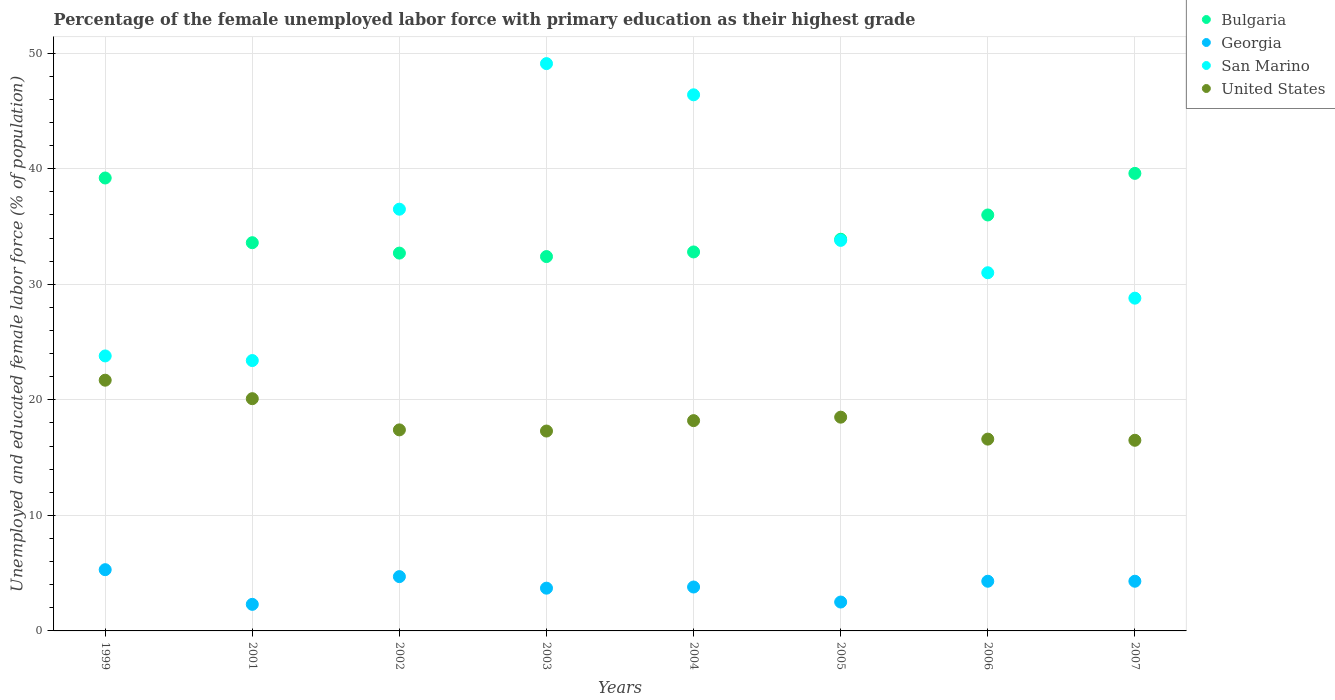How many different coloured dotlines are there?
Give a very brief answer. 4. Is the number of dotlines equal to the number of legend labels?
Offer a terse response. Yes. What is the percentage of the unemployed female labor force with primary education in United States in 2002?
Offer a very short reply. 17.4. Across all years, what is the maximum percentage of the unemployed female labor force with primary education in Bulgaria?
Ensure brevity in your answer.  39.6. Across all years, what is the minimum percentage of the unemployed female labor force with primary education in San Marino?
Your answer should be very brief. 23.4. In which year was the percentage of the unemployed female labor force with primary education in San Marino minimum?
Offer a terse response. 2001. What is the total percentage of the unemployed female labor force with primary education in Bulgaria in the graph?
Keep it short and to the point. 280.2. What is the difference between the percentage of the unemployed female labor force with primary education in United States in 2003 and that in 2006?
Offer a terse response. 0.7. What is the difference between the percentage of the unemployed female labor force with primary education in San Marino in 2006 and the percentage of the unemployed female labor force with primary education in Georgia in 2005?
Ensure brevity in your answer.  28.5. What is the average percentage of the unemployed female labor force with primary education in Bulgaria per year?
Give a very brief answer. 35.03. In the year 2005, what is the difference between the percentage of the unemployed female labor force with primary education in United States and percentage of the unemployed female labor force with primary education in San Marino?
Provide a short and direct response. -15.3. In how many years, is the percentage of the unemployed female labor force with primary education in United States greater than 18 %?
Ensure brevity in your answer.  4. What is the ratio of the percentage of the unemployed female labor force with primary education in United States in 2002 to that in 2003?
Provide a short and direct response. 1.01. Is the percentage of the unemployed female labor force with primary education in San Marino in 1999 less than that in 2006?
Your answer should be very brief. Yes. What is the difference between the highest and the second highest percentage of the unemployed female labor force with primary education in Bulgaria?
Give a very brief answer. 0.4. What is the difference between the highest and the lowest percentage of the unemployed female labor force with primary education in Bulgaria?
Your answer should be very brief. 7.2. Is the sum of the percentage of the unemployed female labor force with primary education in San Marino in 2001 and 2002 greater than the maximum percentage of the unemployed female labor force with primary education in Bulgaria across all years?
Ensure brevity in your answer.  Yes. Is the percentage of the unemployed female labor force with primary education in Georgia strictly less than the percentage of the unemployed female labor force with primary education in San Marino over the years?
Keep it short and to the point. Yes. How many dotlines are there?
Your answer should be very brief. 4. Are the values on the major ticks of Y-axis written in scientific E-notation?
Give a very brief answer. No. What is the title of the graph?
Give a very brief answer. Percentage of the female unemployed labor force with primary education as their highest grade. Does "Niger" appear as one of the legend labels in the graph?
Your answer should be compact. No. What is the label or title of the Y-axis?
Keep it short and to the point. Unemployed and educated female labor force (% of population). What is the Unemployed and educated female labor force (% of population) in Bulgaria in 1999?
Your answer should be very brief. 39.2. What is the Unemployed and educated female labor force (% of population) of Georgia in 1999?
Keep it short and to the point. 5.3. What is the Unemployed and educated female labor force (% of population) of San Marino in 1999?
Your answer should be very brief. 23.8. What is the Unemployed and educated female labor force (% of population) in United States in 1999?
Your answer should be very brief. 21.7. What is the Unemployed and educated female labor force (% of population) of Bulgaria in 2001?
Your answer should be compact. 33.6. What is the Unemployed and educated female labor force (% of population) in Georgia in 2001?
Your response must be concise. 2.3. What is the Unemployed and educated female labor force (% of population) in San Marino in 2001?
Make the answer very short. 23.4. What is the Unemployed and educated female labor force (% of population) of United States in 2001?
Your response must be concise. 20.1. What is the Unemployed and educated female labor force (% of population) of Bulgaria in 2002?
Make the answer very short. 32.7. What is the Unemployed and educated female labor force (% of population) in Georgia in 2002?
Provide a succinct answer. 4.7. What is the Unemployed and educated female labor force (% of population) of San Marino in 2002?
Give a very brief answer. 36.5. What is the Unemployed and educated female labor force (% of population) of United States in 2002?
Your answer should be very brief. 17.4. What is the Unemployed and educated female labor force (% of population) of Bulgaria in 2003?
Offer a very short reply. 32.4. What is the Unemployed and educated female labor force (% of population) of Georgia in 2003?
Provide a short and direct response. 3.7. What is the Unemployed and educated female labor force (% of population) of San Marino in 2003?
Offer a very short reply. 49.1. What is the Unemployed and educated female labor force (% of population) in United States in 2003?
Offer a terse response. 17.3. What is the Unemployed and educated female labor force (% of population) in Bulgaria in 2004?
Offer a very short reply. 32.8. What is the Unemployed and educated female labor force (% of population) in Georgia in 2004?
Your answer should be compact. 3.8. What is the Unemployed and educated female labor force (% of population) in San Marino in 2004?
Provide a short and direct response. 46.4. What is the Unemployed and educated female labor force (% of population) of United States in 2004?
Offer a terse response. 18.2. What is the Unemployed and educated female labor force (% of population) of Bulgaria in 2005?
Your answer should be very brief. 33.9. What is the Unemployed and educated female labor force (% of population) of San Marino in 2005?
Offer a very short reply. 33.8. What is the Unemployed and educated female labor force (% of population) in Bulgaria in 2006?
Your answer should be very brief. 36. What is the Unemployed and educated female labor force (% of population) in Georgia in 2006?
Give a very brief answer. 4.3. What is the Unemployed and educated female labor force (% of population) of United States in 2006?
Give a very brief answer. 16.6. What is the Unemployed and educated female labor force (% of population) of Bulgaria in 2007?
Ensure brevity in your answer.  39.6. What is the Unemployed and educated female labor force (% of population) in Georgia in 2007?
Your answer should be very brief. 4.3. What is the Unemployed and educated female labor force (% of population) in San Marino in 2007?
Your response must be concise. 28.8. Across all years, what is the maximum Unemployed and educated female labor force (% of population) of Bulgaria?
Your answer should be compact. 39.6. Across all years, what is the maximum Unemployed and educated female labor force (% of population) of Georgia?
Offer a very short reply. 5.3. Across all years, what is the maximum Unemployed and educated female labor force (% of population) in San Marino?
Make the answer very short. 49.1. Across all years, what is the maximum Unemployed and educated female labor force (% of population) of United States?
Make the answer very short. 21.7. Across all years, what is the minimum Unemployed and educated female labor force (% of population) in Bulgaria?
Your answer should be compact. 32.4. Across all years, what is the minimum Unemployed and educated female labor force (% of population) of Georgia?
Offer a very short reply. 2.3. Across all years, what is the minimum Unemployed and educated female labor force (% of population) in San Marino?
Make the answer very short. 23.4. Across all years, what is the minimum Unemployed and educated female labor force (% of population) in United States?
Your answer should be very brief. 16.5. What is the total Unemployed and educated female labor force (% of population) of Bulgaria in the graph?
Offer a terse response. 280.2. What is the total Unemployed and educated female labor force (% of population) of Georgia in the graph?
Offer a very short reply. 30.9. What is the total Unemployed and educated female labor force (% of population) of San Marino in the graph?
Your answer should be compact. 272.8. What is the total Unemployed and educated female labor force (% of population) of United States in the graph?
Ensure brevity in your answer.  146.3. What is the difference between the Unemployed and educated female labor force (% of population) of Bulgaria in 1999 and that in 2001?
Provide a short and direct response. 5.6. What is the difference between the Unemployed and educated female labor force (% of population) in Georgia in 1999 and that in 2001?
Keep it short and to the point. 3. What is the difference between the Unemployed and educated female labor force (% of population) of United States in 1999 and that in 2001?
Ensure brevity in your answer.  1.6. What is the difference between the Unemployed and educated female labor force (% of population) in Bulgaria in 1999 and that in 2002?
Offer a very short reply. 6.5. What is the difference between the Unemployed and educated female labor force (% of population) in Georgia in 1999 and that in 2003?
Your answer should be very brief. 1.6. What is the difference between the Unemployed and educated female labor force (% of population) in San Marino in 1999 and that in 2003?
Your answer should be very brief. -25.3. What is the difference between the Unemployed and educated female labor force (% of population) in San Marino in 1999 and that in 2004?
Offer a terse response. -22.6. What is the difference between the Unemployed and educated female labor force (% of population) in United States in 1999 and that in 2005?
Give a very brief answer. 3.2. What is the difference between the Unemployed and educated female labor force (% of population) in Georgia in 1999 and that in 2006?
Your answer should be compact. 1. What is the difference between the Unemployed and educated female labor force (% of population) in San Marino in 1999 and that in 2006?
Give a very brief answer. -7.2. What is the difference between the Unemployed and educated female labor force (% of population) in San Marino in 1999 and that in 2007?
Provide a succinct answer. -5. What is the difference between the Unemployed and educated female labor force (% of population) in United States in 1999 and that in 2007?
Give a very brief answer. 5.2. What is the difference between the Unemployed and educated female labor force (% of population) in Bulgaria in 2001 and that in 2002?
Offer a terse response. 0.9. What is the difference between the Unemployed and educated female labor force (% of population) of United States in 2001 and that in 2002?
Provide a short and direct response. 2.7. What is the difference between the Unemployed and educated female labor force (% of population) in Georgia in 2001 and that in 2003?
Provide a short and direct response. -1.4. What is the difference between the Unemployed and educated female labor force (% of population) of San Marino in 2001 and that in 2003?
Ensure brevity in your answer.  -25.7. What is the difference between the Unemployed and educated female labor force (% of population) of United States in 2001 and that in 2004?
Your answer should be very brief. 1.9. What is the difference between the Unemployed and educated female labor force (% of population) in Bulgaria in 2001 and that in 2005?
Ensure brevity in your answer.  -0.3. What is the difference between the Unemployed and educated female labor force (% of population) of United States in 2001 and that in 2005?
Keep it short and to the point. 1.6. What is the difference between the Unemployed and educated female labor force (% of population) in San Marino in 2001 and that in 2006?
Your answer should be very brief. -7.6. What is the difference between the Unemployed and educated female labor force (% of population) in United States in 2001 and that in 2006?
Keep it short and to the point. 3.5. What is the difference between the Unemployed and educated female labor force (% of population) of Bulgaria in 2001 and that in 2007?
Give a very brief answer. -6. What is the difference between the Unemployed and educated female labor force (% of population) of United States in 2001 and that in 2007?
Give a very brief answer. 3.6. What is the difference between the Unemployed and educated female labor force (% of population) of Bulgaria in 2002 and that in 2003?
Your answer should be compact. 0.3. What is the difference between the Unemployed and educated female labor force (% of population) of Georgia in 2002 and that in 2003?
Offer a very short reply. 1. What is the difference between the Unemployed and educated female labor force (% of population) of United States in 2002 and that in 2003?
Make the answer very short. 0.1. What is the difference between the Unemployed and educated female labor force (% of population) of Bulgaria in 2002 and that in 2004?
Provide a succinct answer. -0.1. What is the difference between the Unemployed and educated female labor force (% of population) in Georgia in 2002 and that in 2004?
Your answer should be very brief. 0.9. What is the difference between the Unemployed and educated female labor force (% of population) in San Marino in 2002 and that in 2004?
Give a very brief answer. -9.9. What is the difference between the Unemployed and educated female labor force (% of population) of United States in 2002 and that in 2004?
Your response must be concise. -0.8. What is the difference between the Unemployed and educated female labor force (% of population) in Bulgaria in 2002 and that in 2005?
Offer a terse response. -1.2. What is the difference between the Unemployed and educated female labor force (% of population) in San Marino in 2002 and that in 2005?
Your answer should be compact. 2.7. What is the difference between the Unemployed and educated female labor force (% of population) of San Marino in 2002 and that in 2006?
Offer a terse response. 5.5. What is the difference between the Unemployed and educated female labor force (% of population) in United States in 2002 and that in 2006?
Your answer should be compact. 0.8. What is the difference between the Unemployed and educated female labor force (% of population) of San Marino in 2002 and that in 2007?
Your answer should be compact. 7.7. What is the difference between the Unemployed and educated female labor force (% of population) in San Marino in 2003 and that in 2004?
Provide a succinct answer. 2.7. What is the difference between the Unemployed and educated female labor force (% of population) of United States in 2003 and that in 2004?
Keep it short and to the point. -0.9. What is the difference between the Unemployed and educated female labor force (% of population) in Bulgaria in 2003 and that in 2005?
Keep it short and to the point. -1.5. What is the difference between the Unemployed and educated female labor force (% of population) of San Marino in 2003 and that in 2005?
Your response must be concise. 15.3. What is the difference between the Unemployed and educated female labor force (% of population) in San Marino in 2003 and that in 2006?
Your response must be concise. 18.1. What is the difference between the Unemployed and educated female labor force (% of population) in Bulgaria in 2003 and that in 2007?
Provide a short and direct response. -7.2. What is the difference between the Unemployed and educated female labor force (% of population) of San Marino in 2003 and that in 2007?
Ensure brevity in your answer.  20.3. What is the difference between the Unemployed and educated female labor force (% of population) of United States in 2003 and that in 2007?
Offer a terse response. 0.8. What is the difference between the Unemployed and educated female labor force (% of population) in San Marino in 2004 and that in 2005?
Your answer should be compact. 12.6. What is the difference between the Unemployed and educated female labor force (% of population) of San Marino in 2004 and that in 2006?
Give a very brief answer. 15.4. What is the difference between the Unemployed and educated female labor force (% of population) in United States in 2004 and that in 2006?
Your answer should be compact. 1.6. What is the difference between the Unemployed and educated female labor force (% of population) of Bulgaria in 2004 and that in 2007?
Keep it short and to the point. -6.8. What is the difference between the Unemployed and educated female labor force (% of population) in Georgia in 2004 and that in 2007?
Your answer should be very brief. -0.5. What is the difference between the Unemployed and educated female labor force (% of population) of Bulgaria in 2005 and that in 2006?
Provide a succinct answer. -2.1. What is the difference between the Unemployed and educated female labor force (% of population) of Georgia in 2005 and that in 2006?
Provide a succinct answer. -1.8. What is the difference between the Unemployed and educated female labor force (% of population) in San Marino in 2005 and that in 2006?
Ensure brevity in your answer.  2.8. What is the difference between the Unemployed and educated female labor force (% of population) of San Marino in 2005 and that in 2007?
Your answer should be very brief. 5. What is the difference between the Unemployed and educated female labor force (% of population) of Bulgaria in 2006 and that in 2007?
Give a very brief answer. -3.6. What is the difference between the Unemployed and educated female labor force (% of population) of United States in 2006 and that in 2007?
Your answer should be very brief. 0.1. What is the difference between the Unemployed and educated female labor force (% of population) of Bulgaria in 1999 and the Unemployed and educated female labor force (% of population) of Georgia in 2001?
Give a very brief answer. 36.9. What is the difference between the Unemployed and educated female labor force (% of population) of Bulgaria in 1999 and the Unemployed and educated female labor force (% of population) of San Marino in 2001?
Provide a succinct answer. 15.8. What is the difference between the Unemployed and educated female labor force (% of population) in Georgia in 1999 and the Unemployed and educated female labor force (% of population) in San Marino in 2001?
Ensure brevity in your answer.  -18.1. What is the difference between the Unemployed and educated female labor force (% of population) in Georgia in 1999 and the Unemployed and educated female labor force (% of population) in United States in 2001?
Make the answer very short. -14.8. What is the difference between the Unemployed and educated female labor force (% of population) in Bulgaria in 1999 and the Unemployed and educated female labor force (% of population) in Georgia in 2002?
Your answer should be compact. 34.5. What is the difference between the Unemployed and educated female labor force (% of population) of Bulgaria in 1999 and the Unemployed and educated female labor force (% of population) of United States in 2002?
Your response must be concise. 21.8. What is the difference between the Unemployed and educated female labor force (% of population) in Georgia in 1999 and the Unemployed and educated female labor force (% of population) in San Marino in 2002?
Your response must be concise. -31.2. What is the difference between the Unemployed and educated female labor force (% of population) in San Marino in 1999 and the Unemployed and educated female labor force (% of population) in United States in 2002?
Your answer should be very brief. 6.4. What is the difference between the Unemployed and educated female labor force (% of population) in Bulgaria in 1999 and the Unemployed and educated female labor force (% of population) in Georgia in 2003?
Ensure brevity in your answer.  35.5. What is the difference between the Unemployed and educated female labor force (% of population) in Bulgaria in 1999 and the Unemployed and educated female labor force (% of population) in San Marino in 2003?
Ensure brevity in your answer.  -9.9. What is the difference between the Unemployed and educated female labor force (% of population) of Bulgaria in 1999 and the Unemployed and educated female labor force (% of population) of United States in 2003?
Keep it short and to the point. 21.9. What is the difference between the Unemployed and educated female labor force (% of population) of Georgia in 1999 and the Unemployed and educated female labor force (% of population) of San Marino in 2003?
Your answer should be compact. -43.8. What is the difference between the Unemployed and educated female labor force (% of population) in Bulgaria in 1999 and the Unemployed and educated female labor force (% of population) in Georgia in 2004?
Provide a short and direct response. 35.4. What is the difference between the Unemployed and educated female labor force (% of population) in Bulgaria in 1999 and the Unemployed and educated female labor force (% of population) in San Marino in 2004?
Your answer should be compact. -7.2. What is the difference between the Unemployed and educated female labor force (% of population) of Bulgaria in 1999 and the Unemployed and educated female labor force (% of population) of United States in 2004?
Ensure brevity in your answer.  21. What is the difference between the Unemployed and educated female labor force (% of population) in Georgia in 1999 and the Unemployed and educated female labor force (% of population) in San Marino in 2004?
Your answer should be compact. -41.1. What is the difference between the Unemployed and educated female labor force (% of population) of Bulgaria in 1999 and the Unemployed and educated female labor force (% of population) of Georgia in 2005?
Make the answer very short. 36.7. What is the difference between the Unemployed and educated female labor force (% of population) of Bulgaria in 1999 and the Unemployed and educated female labor force (% of population) of United States in 2005?
Give a very brief answer. 20.7. What is the difference between the Unemployed and educated female labor force (% of population) in Georgia in 1999 and the Unemployed and educated female labor force (% of population) in San Marino in 2005?
Your response must be concise. -28.5. What is the difference between the Unemployed and educated female labor force (% of population) of Georgia in 1999 and the Unemployed and educated female labor force (% of population) of United States in 2005?
Make the answer very short. -13.2. What is the difference between the Unemployed and educated female labor force (% of population) in San Marino in 1999 and the Unemployed and educated female labor force (% of population) in United States in 2005?
Offer a terse response. 5.3. What is the difference between the Unemployed and educated female labor force (% of population) of Bulgaria in 1999 and the Unemployed and educated female labor force (% of population) of Georgia in 2006?
Provide a succinct answer. 34.9. What is the difference between the Unemployed and educated female labor force (% of population) in Bulgaria in 1999 and the Unemployed and educated female labor force (% of population) in San Marino in 2006?
Keep it short and to the point. 8.2. What is the difference between the Unemployed and educated female labor force (% of population) in Bulgaria in 1999 and the Unemployed and educated female labor force (% of population) in United States in 2006?
Make the answer very short. 22.6. What is the difference between the Unemployed and educated female labor force (% of population) in Georgia in 1999 and the Unemployed and educated female labor force (% of population) in San Marino in 2006?
Keep it short and to the point. -25.7. What is the difference between the Unemployed and educated female labor force (% of population) of Georgia in 1999 and the Unemployed and educated female labor force (% of population) of United States in 2006?
Your response must be concise. -11.3. What is the difference between the Unemployed and educated female labor force (% of population) of San Marino in 1999 and the Unemployed and educated female labor force (% of population) of United States in 2006?
Offer a very short reply. 7.2. What is the difference between the Unemployed and educated female labor force (% of population) of Bulgaria in 1999 and the Unemployed and educated female labor force (% of population) of Georgia in 2007?
Your answer should be compact. 34.9. What is the difference between the Unemployed and educated female labor force (% of population) of Bulgaria in 1999 and the Unemployed and educated female labor force (% of population) of San Marino in 2007?
Your response must be concise. 10.4. What is the difference between the Unemployed and educated female labor force (% of population) in Bulgaria in 1999 and the Unemployed and educated female labor force (% of population) in United States in 2007?
Offer a very short reply. 22.7. What is the difference between the Unemployed and educated female labor force (% of population) in Georgia in 1999 and the Unemployed and educated female labor force (% of population) in San Marino in 2007?
Your answer should be compact. -23.5. What is the difference between the Unemployed and educated female labor force (% of population) in Georgia in 1999 and the Unemployed and educated female labor force (% of population) in United States in 2007?
Provide a succinct answer. -11.2. What is the difference between the Unemployed and educated female labor force (% of population) of Bulgaria in 2001 and the Unemployed and educated female labor force (% of population) of Georgia in 2002?
Provide a short and direct response. 28.9. What is the difference between the Unemployed and educated female labor force (% of population) in Bulgaria in 2001 and the Unemployed and educated female labor force (% of population) in San Marino in 2002?
Your answer should be very brief. -2.9. What is the difference between the Unemployed and educated female labor force (% of population) in Georgia in 2001 and the Unemployed and educated female labor force (% of population) in San Marino in 2002?
Your answer should be very brief. -34.2. What is the difference between the Unemployed and educated female labor force (% of population) in Georgia in 2001 and the Unemployed and educated female labor force (% of population) in United States in 2002?
Offer a terse response. -15.1. What is the difference between the Unemployed and educated female labor force (% of population) of San Marino in 2001 and the Unemployed and educated female labor force (% of population) of United States in 2002?
Offer a very short reply. 6. What is the difference between the Unemployed and educated female labor force (% of population) of Bulgaria in 2001 and the Unemployed and educated female labor force (% of population) of Georgia in 2003?
Make the answer very short. 29.9. What is the difference between the Unemployed and educated female labor force (% of population) in Bulgaria in 2001 and the Unemployed and educated female labor force (% of population) in San Marino in 2003?
Offer a very short reply. -15.5. What is the difference between the Unemployed and educated female labor force (% of population) of Georgia in 2001 and the Unemployed and educated female labor force (% of population) of San Marino in 2003?
Your response must be concise. -46.8. What is the difference between the Unemployed and educated female labor force (% of population) in Georgia in 2001 and the Unemployed and educated female labor force (% of population) in United States in 2003?
Your response must be concise. -15. What is the difference between the Unemployed and educated female labor force (% of population) of San Marino in 2001 and the Unemployed and educated female labor force (% of population) of United States in 2003?
Your answer should be compact. 6.1. What is the difference between the Unemployed and educated female labor force (% of population) in Bulgaria in 2001 and the Unemployed and educated female labor force (% of population) in Georgia in 2004?
Offer a very short reply. 29.8. What is the difference between the Unemployed and educated female labor force (% of population) of Bulgaria in 2001 and the Unemployed and educated female labor force (% of population) of United States in 2004?
Give a very brief answer. 15.4. What is the difference between the Unemployed and educated female labor force (% of population) of Georgia in 2001 and the Unemployed and educated female labor force (% of population) of San Marino in 2004?
Keep it short and to the point. -44.1. What is the difference between the Unemployed and educated female labor force (% of population) in Georgia in 2001 and the Unemployed and educated female labor force (% of population) in United States in 2004?
Offer a very short reply. -15.9. What is the difference between the Unemployed and educated female labor force (% of population) of Bulgaria in 2001 and the Unemployed and educated female labor force (% of population) of Georgia in 2005?
Your response must be concise. 31.1. What is the difference between the Unemployed and educated female labor force (% of population) in Bulgaria in 2001 and the Unemployed and educated female labor force (% of population) in San Marino in 2005?
Give a very brief answer. -0.2. What is the difference between the Unemployed and educated female labor force (% of population) in Bulgaria in 2001 and the Unemployed and educated female labor force (% of population) in United States in 2005?
Provide a succinct answer. 15.1. What is the difference between the Unemployed and educated female labor force (% of population) in Georgia in 2001 and the Unemployed and educated female labor force (% of population) in San Marino in 2005?
Keep it short and to the point. -31.5. What is the difference between the Unemployed and educated female labor force (% of population) in Georgia in 2001 and the Unemployed and educated female labor force (% of population) in United States in 2005?
Provide a succinct answer. -16.2. What is the difference between the Unemployed and educated female labor force (% of population) in San Marino in 2001 and the Unemployed and educated female labor force (% of population) in United States in 2005?
Your response must be concise. 4.9. What is the difference between the Unemployed and educated female labor force (% of population) of Bulgaria in 2001 and the Unemployed and educated female labor force (% of population) of Georgia in 2006?
Keep it short and to the point. 29.3. What is the difference between the Unemployed and educated female labor force (% of population) of Bulgaria in 2001 and the Unemployed and educated female labor force (% of population) of United States in 2006?
Offer a terse response. 17. What is the difference between the Unemployed and educated female labor force (% of population) in Georgia in 2001 and the Unemployed and educated female labor force (% of population) in San Marino in 2006?
Provide a succinct answer. -28.7. What is the difference between the Unemployed and educated female labor force (% of population) in Georgia in 2001 and the Unemployed and educated female labor force (% of population) in United States in 2006?
Offer a very short reply. -14.3. What is the difference between the Unemployed and educated female labor force (% of population) of Bulgaria in 2001 and the Unemployed and educated female labor force (% of population) of Georgia in 2007?
Make the answer very short. 29.3. What is the difference between the Unemployed and educated female labor force (% of population) in Bulgaria in 2001 and the Unemployed and educated female labor force (% of population) in San Marino in 2007?
Ensure brevity in your answer.  4.8. What is the difference between the Unemployed and educated female labor force (% of population) of Georgia in 2001 and the Unemployed and educated female labor force (% of population) of San Marino in 2007?
Make the answer very short. -26.5. What is the difference between the Unemployed and educated female labor force (% of population) of Bulgaria in 2002 and the Unemployed and educated female labor force (% of population) of San Marino in 2003?
Offer a very short reply. -16.4. What is the difference between the Unemployed and educated female labor force (% of population) in Bulgaria in 2002 and the Unemployed and educated female labor force (% of population) in United States in 2003?
Offer a very short reply. 15.4. What is the difference between the Unemployed and educated female labor force (% of population) in Georgia in 2002 and the Unemployed and educated female labor force (% of population) in San Marino in 2003?
Provide a succinct answer. -44.4. What is the difference between the Unemployed and educated female labor force (% of population) in Georgia in 2002 and the Unemployed and educated female labor force (% of population) in United States in 2003?
Provide a succinct answer. -12.6. What is the difference between the Unemployed and educated female labor force (% of population) of Bulgaria in 2002 and the Unemployed and educated female labor force (% of population) of Georgia in 2004?
Your answer should be very brief. 28.9. What is the difference between the Unemployed and educated female labor force (% of population) in Bulgaria in 2002 and the Unemployed and educated female labor force (% of population) in San Marino in 2004?
Make the answer very short. -13.7. What is the difference between the Unemployed and educated female labor force (% of population) in Bulgaria in 2002 and the Unemployed and educated female labor force (% of population) in United States in 2004?
Offer a terse response. 14.5. What is the difference between the Unemployed and educated female labor force (% of population) of Georgia in 2002 and the Unemployed and educated female labor force (% of population) of San Marino in 2004?
Your answer should be very brief. -41.7. What is the difference between the Unemployed and educated female labor force (% of population) of Bulgaria in 2002 and the Unemployed and educated female labor force (% of population) of Georgia in 2005?
Provide a succinct answer. 30.2. What is the difference between the Unemployed and educated female labor force (% of population) in Bulgaria in 2002 and the Unemployed and educated female labor force (% of population) in San Marino in 2005?
Provide a succinct answer. -1.1. What is the difference between the Unemployed and educated female labor force (% of population) in Georgia in 2002 and the Unemployed and educated female labor force (% of population) in San Marino in 2005?
Give a very brief answer. -29.1. What is the difference between the Unemployed and educated female labor force (% of population) in San Marino in 2002 and the Unemployed and educated female labor force (% of population) in United States in 2005?
Keep it short and to the point. 18. What is the difference between the Unemployed and educated female labor force (% of population) in Bulgaria in 2002 and the Unemployed and educated female labor force (% of population) in Georgia in 2006?
Make the answer very short. 28.4. What is the difference between the Unemployed and educated female labor force (% of population) in Bulgaria in 2002 and the Unemployed and educated female labor force (% of population) in United States in 2006?
Offer a terse response. 16.1. What is the difference between the Unemployed and educated female labor force (% of population) of Georgia in 2002 and the Unemployed and educated female labor force (% of population) of San Marino in 2006?
Your response must be concise. -26.3. What is the difference between the Unemployed and educated female labor force (% of population) of Bulgaria in 2002 and the Unemployed and educated female labor force (% of population) of Georgia in 2007?
Provide a short and direct response. 28.4. What is the difference between the Unemployed and educated female labor force (% of population) in Georgia in 2002 and the Unemployed and educated female labor force (% of population) in San Marino in 2007?
Your response must be concise. -24.1. What is the difference between the Unemployed and educated female labor force (% of population) of Bulgaria in 2003 and the Unemployed and educated female labor force (% of population) of Georgia in 2004?
Make the answer very short. 28.6. What is the difference between the Unemployed and educated female labor force (% of population) of Bulgaria in 2003 and the Unemployed and educated female labor force (% of population) of San Marino in 2004?
Your answer should be very brief. -14. What is the difference between the Unemployed and educated female labor force (% of population) of Bulgaria in 2003 and the Unemployed and educated female labor force (% of population) of United States in 2004?
Offer a very short reply. 14.2. What is the difference between the Unemployed and educated female labor force (% of population) of Georgia in 2003 and the Unemployed and educated female labor force (% of population) of San Marino in 2004?
Keep it short and to the point. -42.7. What is the difference between the Unemployed and educated female labor force (% of population) in San Marino in 2003 and the Unemployed and educated female labor force (% of population) in United States in 2004?
Keep it short and to the point. 30.9. What is the difference between the Unemployed and educated female labor force (% of population) of Bulgaria in 2003 and the Unemployed and educated female labor force (% of population) of Georgia in 2005?
Give a very brief answer. 29.9. What is the difference between the Unemployed and educated female labor force (% of population) of Bulgaria in 2003 and the Unemployed and educated female labor force (% of population) of San Marino in 2005?
Make the answer very short. -1.4. What is the difference between the Unemployed and educated female labor force (% of population) of Bulgaria in 2003 and the Unemployed and educated female labor force (% of population) of United States in 2005?
Give a very brief answer. 13.9. What is the difference between the Unemployed and educated female labor force (% of population) of Georgia in 2003 and the Unemployed and educated female labor force (% of population) of San Marino in 2005?
Provide a short and direct response. -30.1. What is the difference between the Unemployed and educated female labor force (% of population) in Georgia in 2003 and the Unemployed and educated female labor force (% of population) in United States in 2005?
Make the answer very short. -14.8. What is the difference between the Unemployed and educated female labor force (% of population) in San Marino in 2003 and the Unemployed and educated female labor force (% of population) in United States in 2005?
Keep it short and to the point. 30.6. What is the difference between the Unemployed and educated female labor force (% of population) in Bulgaria in 2003 and the Unemployed and educated female labor force (% of population) in Georgia in 2006?
Make the answer very short. 28.1. What is the difference between the Unemployed and educated female labor force (% of population) in Georgia in 2003 and the Unemployed and educated female labor force (% of population) in San Marino in 2006?
Your answer should be compact. -27.3. What is the difference between the Unemployed and educated female labor force (% of population) in San Marino in 2003 and the Unemployed and educated female labor force (% of population) in United States in 2006?
Your answer should be very brief. 32.5. What is the difference between the Unemployed and educated female labor force (% of population) in Bulgaria in 2003 and the Unemployed and educated female labor force (% of population) in Georgia in 2007?
Provide a short and direct response. 28.1. What is the difference between the Unemployed and educated female labor force (% of population) in Bulgaria in 2003 and the Unemployed and educated female labor force (% of population) in United States in 2007?
Your response must be concise. 15.9. What is the difference between the Unemployed and educated female labor force (% of population) in Georgia in 2003 and the Unemployed and educated female labor force (% of population) in San Marino in 2007?
Offer a very short reply. -25.1. What is the difference between the Unemployed and educated female labor force (% of population) of Georgia in 2003 and the Unemployed and educated female labor force (% of population) of United States in 2007?
Keep it short and to the point. -12.8. What is the difference between the Unemployed and educated female labor force (% of population) in San Marino in 2003 and the Unemployed and educated female labor force (% of population) in United States in 2007?
Offer a very short reply. 32.6. What is the difference between the Unemployed and educated female labor force (% of population) in Bulgaria in 2004 and the Unemployed and educated female labor force (% of population) in Georgia in 2005?
Your answer should be compact. 30.3. What is the difference between the Unemployed and educated female labor force (% of population) of Bulgaria in 2004 and the Unemployed and educated female labor force (% of population) of United States in 2005?
Ensure brevity in your answer.  14.3. What is the difference between the Unemployed and educated female labor force (% of population) in Georgia in 2004 and the Unemployed and educated female labor force (% of population) in San Marino in 2005?
Offer a terse response. -30. What is the difference between the Unemployed and educated female labor force (% of population) of Georgia in 2004 and the Unemployed and educated female labor force (% of population) of United States in 2005?
Offer a very short reply. -14.7. What is the difference between the Unemployed and educated female labor force (% of population) in San Marino in 2004 and the Unemployed and educated female labor force (% of population) in United States in 2005?
Ensure brevity in your answer.  27.9. What is the difference between the Unemployed and educated female labor force (% of population) of Bulgaria in 2004 and the Unemployed and educated female labor force (% of population) of United States in 2006?
Your answer should be compact. 16.2. What is the difference between the Unemployed and educated female labor force (% of population) of Georgia in 2004 and the Unemployed and educated female labor force (% of population) of San Marino in 2006?
Make the answer very short. -27.2. What is the difference between the Unemployed and educated female labor force (% of population) in San Marino in 2004 and the Unemployed and educated female labor force (% of population) in United States in 2006?
Provide a succinct answer. 29.8. What is the difference between the Unemployed and educated female labor force (% of population) in San Marino in 2004 and the Unemployed and educated female labor force (% of population) in United States in 2007?
Provide a succinct answer. 29.9. What is the difference between the Unemployed and educated female labor force (% of population) in Bulgaria in 2005 and the Unemployed and educated female labor force (% of population) in Georgia in 2006?
Your answer should be very brief. 29.6. What is the difference between the Unemployed and educated female labor force (% of population) of Bulgaria in 2005 and the Unemployed and educated female labor force (% of population) of San Marino in 2006?
Offer a terse response. 2.9. What is the difference between the Unemployed and educated female labor force (% of population) in Bulgaria in 2005 and the Unemployed and educated female labor force (% of population) in United States in 2006?
Ensure brevity in your answer.  17.3. What is the difference between the Unemployed and educated female labor force (% of population) of Georgia in 2005 and the Unemployed and educated female labor force (% of population) of San Marino in 2006?
Give a very brief answer. -28.5. What is the difference between the Unemployed and educated female labor force (% of population) of Georgia in 2005 and the Unemployed and educated female labor force (% of population) of United States in 2006?
Offer a very short reply. -14.1. What is the difference between the Unemployed and educated female labor force (% of population) in San Marino in 2005 and the Unemployed and educated female labor force (% of population) in United States in 2006?
Your answer should be compact. 17.2. What is the difference between the Unemployed and educated female labor force (% of population) in Bulgaria in 2005 and the Unemployed and educated female labor force (% of population) in Georgia in 2007?
Make the answer very short. 29.6. What is the difference between the Unemployed and educated female labor force (% of population) in Bulgaria in 2005 and the Unemployed and educated female labor force (% of population) in San Marino in 2007?
Keep it short and to the point. 5.1. What is the difference between the Unemployed and educated female labor force (% of population) in Bulgaria in 2005 and the Unemployed and educated female labor force (% of population) in United States in 2007?
Your answer should be very brief. 17.4. What is the difference between the Unemployed and educated female labor force (% of population) of Georgia in 2005 and the Unemployed and educated female labor force (% of population) of San Marino in 2007?
Your answer should be very brief. -26.3. What is the difference between the Unemployed and educated female labor force (% of population) of San Marino in 2005 and the Unemployed and educated female labor force (% of population) of United States in 2007?
Make the answer very short. 17.3. What is the difference between the Unemployed and educated female labor force (% of population) of Bulgaria in 2006 and the Unemployed and educated female labor force (% of population) of Georgia in 2007?
Provide a succinct answer. 31.7. What is the difference between the Unemployed and educated female labor force (% of population) in Bulgaria in 2006 and the Unemployed and educated female labor force (% of population) in San Marino in 2007?
Your response must be concise. 7.2. What is the difference between the Unemployed and educated female labor force (% of population) in Georgia in 2006 and the Unemployed and educated female labor force (% of population) in San Marino in 2007?
Give a very brief answer. -24.5. What is the difference between the Unemployed and educated female labor force (% of population) of San Marino in 2006 and the Unemployed and educated female labor force (% of population) of United States in 2007?
Make the answer very short. 14.5. What is the average Unemployed and educated female labor force (% of population) in Bulgaria per year?
Your answer should be very brief. 35.02. What is the average Unemployed and educated female labor force (% of population) in Georgia per year?
Ensure brevity in your answer.  3.86. What is the average Unemployed and educated female labor force (% of population) of San Marino per year?
Your answer should be compact. 34.1. What is the average Unemployed and educated female labor force (% of population) in United States per year?
Give a very brief answer. 18.29. In the year 1999, what is the difference between the Unemployed and educated female labor force (% of population) in Bulgaria and Unemployed and educated female labor force (% of population) in Georgia?
Your answer should be compact. 33.9. In the year 1999, what is the difference between the Unemployed and educated female labor force (% of population) of Bulgaria and Unemployed and educated female labor force (% of population) of United States?
Your response must be concise. 17.5. In the year 1999, what is the difference between the Unemployed and educated female labor force (% of population) in Georgia and Unemployed and educated female labor force (% of population) in San Marino?
Your answer should be compact. -18.5. In the year 1999, what is the difference between the Unemployed and educated female labor force (% of population) of Georgia and Unemployed and educated female labor force (% of population) of United States?
Make the answer very short. -16.4. In the year 1999, what is the difference between the Unemployed and educated female labor force (% of population) in San Marino and Unemployed and educated female labor force (% of population) in United States?
Provide a succinct answer. 2.1. In the year 2001, what is the difference between the Unemployed and educated female labor force (% of population) of Bulgaria and Unemployed and educated female labor force (% of population) of Georgia?
Your answer should be very brief. 31.3. In the year 2001, what is the difference between the Unemployed and educated female labor force (% of population) of Bulgaria and Unemployed and educated female labor force (% of population) of San Marino?
Keep it short and to the point. 10.2. In the year 2001, what is the difference between the Unemployed and educated female labor force (% of population) of Georgia and Unemployed and educated female labor force (% of population) of San Marino?
Ensure brevity in your answer.  -21.1. In the year 2001, what is the difference between the Unemployed and educated female labor force (% of population) of Georgia and Unemployed and educated female labor force (% of population) of United States?
Provide a succinct answer. -17.8. In the year 2002, what is the difference between the Unemployed and educated female labor force (% of population) of Bulgaria and Unemployed and educated female labor force (% of population) of San Marino?
Ensure brevity in your answer.  -3.8. In the year 2002, what is the difference between the Unemployed and educated female labor force (% of population) in Georgia and Unemployed and educated female labor force (% of population) in San Marino?
Keep it short and to the point. -31.8. In the year 2002, what is the difference between the Unemployed and educated female labor force (% of population) in Georgia and Unemployed and educated female labor force (% of population) in United States?
Ensure brevity in your answer.  -12.7. In the year 2002, what is the difference between the Unemployed and educated female labor force (% of population) of San Marino and Unemployed and educated female labor force (% of population) of United States?
Offer a very short reply. 19.1. In the year 2003, what is the difference between the Unemployed and educated female labor force (% of population) of Bulgaria and Unemployed and educated female labor force (% of population) of Georgia?
Your response must be concise. 28.7. In the year 2003, what is the difference between the Unemployed and educated female labor force (% of population) in Bulgaria and Unemployed and educated female labor force (% of population) in San Marino?
Offer a very short reply. -16.7. In the year 2003, what is the difference between the Unemployed and educated female labor force (% of population) in Bulgaria and Unemployed and educated female labor force (% of population) in United States?
Give a very brief answer. 15.1. In the year 2003, what is the difference between the Unemployed and educated female labor force (% of population) of Georgia and Unemployed and educated female labor force (% of population) of San Marino?
Your answer should be compact. -45.4. In the year 2003, what is the difference between the Unemployed and educated female labor force (% of population) in Georgia and Unemployed and educated female labor force (% of population) in United States?
Provide a succinct answer. -13.6. In the year 2003, what is the difference between the Unemployed and educated female labor force (% of population) in San Marino and Unemployed and educated female labor force (% of population) in United States?
Your answer should be compact. 31.8. In the year 2004, what is the difference between the Unemployed and educated female labor force (% of population) of Bulgaria and Unemployed and educated female labor force (% of population) of Georgia?
Your answer should be compact. 29. In the year 2004, what is the difference between the Unemployed and educated female labor force (% of population) of Bulgaria and Unemployed and educated female labor force (% of population) of San Marino?
Offer a very short reply. -13.6. In the year 2004, what is the difference between the Unemployed and educated female labor force (% of population) in Bulgaria and Unemployed and educated female labor force (% of population) in United States?
Ensure brevity in your answer.  14.6. In the year 2004, what is the difference between the Unemployed and educated female labor force (% of population) of Georgia and Unemployed and educated female labor force (% of population) of San Marino?
Provide a succinct answer. -42.6. In the year 2004, what is the difference between the Unemployed and educated female labor force (% of population) of Georgia and Unemployed and educated female labor force (% of population) of United States?
Offer a very short reply. -14.4. In the year 2004, what is the difference between the Unemployed and educated female labor force (% of population) in San Marino and Unemployed and educated female labor force (% of population) in United States?
Ensure brevity in your answer.  28.2. In the year 2005, what is the difference between the Unemployed and educated female labor force (% of population) of Bulgaria and Unemployed and educated female labor force (% of population) of Georgia?
Your answer should be very brief. 31.4. In the year 2005, what is the difference between the Unemployed and educated female labor force (% of population) in Bulgaria and Unemployed and educated female labor force (% of population) in San Marino?
Ensure brevity in your answer.  0.1. In the year 2005, what is the difference between the Unemployed and educated female labor force (% of population) in Georgia and Unemployed and educated female labor force (% of population) in San Marino?
Offer a terse response. -31.3. In the year 2006, what is the difference between the Unemployed and educated female labor force (% of population) of Bulgaria and Unemployed and educated female labor force (% of population) of Georgia?
Ensure brevity in your answer.  31.7. In the year 2006, what is the difference between the Unemployed and educated female labor force (% of population) of Georgia and Unemployed and educated female labor force (% of population) of San Marino?
Ensure brevity in your answer.  -26.7. In the year 2006, what is the difference between the Unemployed and educated female labor force (% of population) of Georgia and Unemployed and educated female labor force (% of population) of United States?
Make the answer very short. -12.3. In the year 2007, what is the difference between the Unemployed and educated female labor force (% of population) in Bulgaria and Unemployed and educated female labor force (% of population) in Georgia?
Make the answer very short. 35.3. In the year 2007, what is the difference between the Unemployed and educated female labor force (% of population) of Bulgaria and Unemployed and educated female labor force (% of population) of San Marino?
Keep it short and to the point. 10.8. In the year 2007, what is the difference between the Unemployed and educated female labor force (% of population) in Bulgaria and Unemployed and educated female labor force (% of population) in United States?
Provide a succinct answer. 23.1. In the year 2007, what is the difference between the Unemployed and educated female labor force (% of population) of Georgia and Unemployed and educated female labor force (% of population) of San Marino?
Provide a succinct answer. -24.5. In the year 2007, what is the difference between the Unemployed and educated female labor force (% of population) in Georgia and Unemployed and educated female labor force (% of population) in United States?
Give a very brief answer. -12.2. In the year 2007, what is the difference between the Unemployed and educated female labor force (% of population) in San Marino and Unemployed and educated female labor force (% of population) in United States?
Provide a succinct answer. 12.3. What is the ratio of the Unemployed and educated female labor force (% of population) in Bulgaria in 1999 to that in 2001?
Make the answer very short. 1.17. What is the ratio of the Unemployed and educated female labor force (% of population) of Georgia in 1999 to that in 2001?
Your response must be concise. 2.3. What is the ratio of the Unemployed and educated female labor force (% of population) in San Marino in 1999 to that in 2001?
Provide a short and direct response. 1.02. What is the ratio of the Unemployed and educated female labor force (% of population) of United States in 1999 to that in 2001?
Offer a terse response. 1.08. What is the ratio of the Unemployed and educated female labor force (% of population) of Bulgaria in 1999 to that in 2002?
Ensure brevity in your answer.  1.2. What is the ratio of the Unemployed and educated female labor force (% of population) in Georgia in 1999 to that in 2002?
Provide a short and direct response. 1.13. What is the ratio of the Unemployed and educated female labor force (% of population) of San Marino in 1999 to that in 2002?
Keep it short and to the point. 0.65. What is the ratio of the Unemployed and educated female labor force (% of population) in United States in 1999 to that in 2002?
Ensure brevity in your answer.  1.25. What is the ratio of the Unemployed and educated female labor force (% of population) in Bulgaria in 1999 to that in 2003?
Keep it short and to the point. 1.21. What is the ratio of the Unemployed and educated female labor force (% of population) of Georgia in 1999 to that in 2003?
Your response must be concise. 1.43. What is the ratio of the Unemployed and educated female labor force (% of population) in San Marino in 1999 to that in 2003?
Provide a succinct answer. 0.48. What is the ratio of the Unemployed and educated female labor force (% of population) in United States in 1999 to that in 2003?
Your answer should be very brief. 1.25. What is the ratio of the Unemployed and educated female labor force (% of population) of Bulgaria in 1999 to that in 2004?
Offer a terse response. 1.2. What is the ratio of the Unemployed and educated female labor force (% of population) of Georgia in 1999 to that in 2004?
Your answer should be very brief. 1.39. What is the ratio of the Unemployed and educated female labor force (% of population) of San Marino in 1999 to that in 2004?
Provide a succinct answer. 0.51. What is the ratio of the Unemployed and educated female labor force (% of population) in United States in 1999 to that in 2004?
Provide a short and direct response. 1.19. What is the ratio of the Unemployed and educated female labor force (% of population) of Bulgaria in 1999 to that in 2005?
Offer a terse response. 1.16. What is the ratio of the Unemployed and educated female labor force (% of population) in Georgia in 1999 to that in 2005?
Your answer should be compact. 2.12. What is the ratio of the Unemployed and educated female labor force (% of population) of San Marino in 1999 to that in 2005?
Your response must be concise. 0.7. What is the ratio of the Unemployed and educated female labor force (% of population) in United States in 1999 to that in 2005?
Provide a short and direct response. 1.17. What is the ratio of the Unemployed and educated female labor force (% of population) in Bulgaria in 1999 to that in 2006?
Ensure brevity in your answer.  1.09. What is the ratio of the Unemployed and educated female labor force (% of population) in Georgia in 1999 to that in 2006?
Keep it short and to the point. 1.23. What is the ratio of the Unemployed and educated female labor force (% of population) in San Marino in 1999 to that in 2006?
Your response must be concise. 0.77. What is the ratio of the Unemployed and educated female labor force (% of population) in United States in 1999 to that in 2006?
Keep it short and to the point. 1.31. What is the ratio of the Unemployed and educated female labor force (% of population) of Georgia in 1999 to that in 2007?
Your answer should be very brief. 1.23. What is the ratio of the Unemployed and educated female labor force (% of population) of San Marino in 1999 to that in 2007?
Give a very brief answer. 0.83. What is the ratio of the Unemployed and educated female labor force (% of population) of United States in 1999 to that in 2007?
Offer a terse response. 1.32. What is the ratio of the Unemployed and educated female labor force (% of population) in Bulgaria in 2001 to that in 2002?
Make the answer very short. 1.03. What is the ratio of the Unemployed and educated female labor force (% of population) in Georgia in 2001 to that in 2002?
Keep it short and to the point. 0.49. What is the ratio of the Unemployed and educated female labor force (% of population) of San Marino in 2001 to that in 2002?
Your answer should be very brief. 0.64. What is the ratio of the Unemployed and educated female labor force (% of population) of United States in 2001 to that in 2002?
Your response must be concise. 1.16. What is the ratio of the Unemployed and educated female labor force (% of population) in Georgia in 2001 to that in 2003?
Keep it short and to the point. 0.62. What is the ratio of the Unemployed and educated female labor force (% of population) of San Marino in 2001 to that in 2003?
Offer a very short reply. 0.48. What is the ratio of the Unemployed and educated female labor force (% of population) in United States in 2001 to that in 2003?
Offer a very short reply. 1.16. What is the ratio of the Unemployed and educated female labor force (% of population) in Bulgaria in 2001 to that in 2004?
Offer a terse response. 1.02. What is the ratio of the Unemployed and educated female labor force (% of population) in Georgia in 2001 to that in 2004?
Ensure brevity in your answer.  0.61. What is the ratio of the Unemployed and educated female labor force (% of population) in San Marino in 2001 to that in 2004?
Your answer should be compact. 0.5. What is the ratio of the Unemployed and educated female labor force (% of population) of United States in 2001 to that in 2004?
Your response must be concise. 1.1. What is the ratio of the Unemployed and educated female labor force (% of population) of San Marino in 2001 to that in 2005?
Give a very brief answer. 0.69. What is the ratio of the Unemployed and educated female labor force (% of population) in United States in 2001 to that in 2005?
Give a very brief answer. 1.09. What is the ratio of the Unemployed and educated female labor force (% of population) in Bulgaria in 2001 to that in 2006?
Give a very brief answer. 0.93. What is the ratio of the Unemployed and educated female labor force (% of population) of Georgia in 2001 to that in 2006?
Your response must be concise. 0.53. What is the ratio of the Unemployed and educated female labor force (% of population) in San Marino in 2001 to that in 2006?
Your answer should be compact. 0.75. What is the ratio of the Unemployed and educated female labor force (% of population) in United States in 2001 to that in 2006?
Make the answer very short. 1.21. What is the ratio of the Unemployed and educated female labor force (% of population) of Bulgaria in 2001 to that in 2007?
Provide a succinct answer. 0.85. What is the ratio of the Unemployed and educated female labor force (% of population) in Georgia in 2001 to that in 2007?
Your response must be concise. 0.53. What is the ratio of the Unemployed and educated female labor force (% of population) of San Marino in 2001 to that in 2007?
Offer a very short reply. 0.81. What is the ratio of the Unemployed and educated female labor force (% of population) of United States in 2001 to that in 2007?
Ensure brevity in your answer.  1.22. What is the ratio of the Unemployed and educated female labor force (% of population) in Bulgaria in 2002 to that in 2003?
Your response must be concise. 1.01. What is the ratio of the Unemployed and educated female labor force (% of population) in Georgia in 2002 to that in 2003?
Offer a very short reply. 1.27. What is the ratio of the Unemployed and educated female labor force (% of population) in San Marino in 2002 to that in 2003?
Your response must be concise. 0.74. What is the ratio of the Unemployed and educated female labor force (% of population) in Georgia in 2002 to that in 2004?
Your answer should be very brief. 1.24. What is the ratio of the Unemployed and educated female labor force (% of population) in San Marino in 2002 to that in 2004?
Your answer should be compact. 0.79. What is the ratio of the Unemployed and educated female labor force (% of population) of United States in 2002 to that in 2004?
Ensure brevity in your answer.  0.96. What is the ratio of the Unemployed and educated female labor force (% of population) of Bulgaria in 2002 to that in 2005?
Keep it short and to the point. 0.96. What is the ratio of the Unemployed and educated female labor force (% of population) in Georgia in 2002 to that in 2005?
Your response must be concise. 1.88. What is the ratio of the Unemployed and educated female labor force (% of population) of San Marino in 2002 to that in 2005?
Provide a succinct answer. 1.08. What is the ratio of the Unemployed and educated female labor force (% of population) of United States in 2002 to that in 2005?
Provide a succinct answer. 0.94. What is the ratio of the Unemployed and educated female labor force (% of population) in Bulgaria in 2002 to that in 2006?
Your answer should be compact. 0.91. What is the ratio of the Unemployed and educated female labor force (% of population) of Georgia in 2002 to that in 2006?
Your answer should be very brief. 1.09. What is the ratio of the Unemployed and educated female labor force (% of population) in San Marino in 2002 to that in 2006?
Keep it short and to the point. 1.18. What is the ratio of the Unemployed and educated female labor force (% of population) of United States in 2002 to that in 2006?
Ensure brevity in your answer.  1.05. What is the ratio of the Unemployed and educated female labor force (% of population) of Bulgaria in 2002 to that in 2007?
Provide a short and direct response. 0.83. What is the ratio of the Unemployed and educated female labor force (% of population) in Georgia in 2002 to that in 2007?
Provide a succinct answer. 1.09. What is the ratio of the Unemployed and educated female labor force (% of population) of San Marino in 2002 to that in 2007?
Provide a succinct answer. 1.27. What is the ratio of the Unemployed and educated female labor force (% of population) in United States in 2002 to that in 2007?
Provide a succinct answer. 1.05. What is the ratio of the Unemployed and educated female labor force (% of population) in Georgia in 2003 to that in 2004?
Your answer should be very brief. 0.97. What is the ratio of the Unemployed and educated female labor force (% of population) in San Marino in 2003 to that in 2004?
Keep it short and to the point. 1.06. What is the ratio of the Unemployed and educated female labor force (% of population) of United States in 2003 to that in 2004?
Make the answer very short. 0.95. What is the ratio of the Unemployed and educated female labor force (% of population) of Bulgaria in 2003 to that in 2005?
Ensure brevity in your answer.  0.96. What is the ratio of the Unemployed and educated female labor force (% of population) of Georgia in 2003 to that in 2005?
Give a very brief answer. 1.48. What is the ratio of the Unemployed and educated female labor force (% of population) in San Marino in 2003 to that in 2005?
Provide a succinct answer. 1.45. What is the ratio of the Unemployed and educated female labor force (% of population) in United States in 2003 to that in 2005?
Offer a very short reply. 0.94. What is the ratio of the Unemployed and educated female labor force (% of population) in Georgia in 2003 to that in 2006?
Offer a terse response. 0.86. What is the ratio of the Unemployed and educated female labor force (% of population) of San Marino in 2003 to that in 2006?
Provide a succinct answer. 1.58. What is the ratio of the Unemployed and educated female labor force (% of population) in United States in 2003 to that in 2006?
Make the answer very short. 1.04. What is the ratio of the Unemployed and educated female labor force (% of population) in Bulgaria in 2003 to that in 2007?
Offer a terse response. 0.82. What is the ratio of the Unemployed and educated female labor force (% of population) in Georgia in 2003 to that in 2007?
Your answer should be compact. 0.86. What is the ratio of the Unemployed and educated female labor force (% of population) of San Marino in 2003 to that in 2007?
Offer a very short reply. 1.7. What is the ratio of the Unemployed and educated female labor force (% of population) in United States in 2003 to that in 2007?
Make the answer very short. 1.05. What is the ratio of the Unemployed and educated female labor force (% of population) in Bulgaria in 2004 to that in 2005?
Provide a short and direct response. 0.97. What is the ratio of the Unemployed and educated female labor force (% of population) in Georgia in 2004 to that in 2005?
Give a very brief answer. 1.52. What is the ratio of the Unemployed and educated female labor force (% of population) of San Marino in 2004 to that in 2005?
Provide a succinct answer. 1.37. What is the ratio of the Unemployed and educated female labor force (% of population) of United States in 2004 to that in 2005?
Keep it short and to the point. 0.98. What is the ratio of the Unemployed and educated female labor force (% of population) in Bulgaria in 2004 to that in 2006?
Your answer should be very brief. 0.91. What is the ratio of the Unemployed and educated female labor force (% of population) in Georgia in 2004 to that in 2006?
Provide a succinct answer. 0.88. What is the ratio of the Unemployed and educated female labor force (% of population) of San Marino in 2004 to that in 2006?
Give a very brief answer. 1.5. What is the ratio of the Unemployed and educated female labor force (% of population) of United States in 2004 to that in 2006?
Your response must be concise. 1.1. What is the ratio of the Unemployed and educated female labor force (% of population) of Bulgaria in 2004 to that in 2007?
Offer a terse response. 0.83. What is the ratio of the Unemployed and educated female labor force (% of population) of Georgia in 2004 to that in 2007?
Offer a terse response. 0.88. What is the ratio of the Unemployed and educated female labor force (% of population) of San Marino in 2004 to that in 2007?
Make the answer very short. 1.61. What is the ratio of the Unemployed and educated female labor force (% of population) in United States in 2004 to that in 2007?
Keep it short and to the point. 1.1. What is the ratio of the Unemployed and educated female labor force (% of population) in Bulgaria in 2005 to that in 2006?
Offer a terse response. 0.94. What is the ratio of the Unemployed and educated female labor force (% of population) in Georgia in 2005 to that in 2006?
Give a very brief answer. 0.58. What is the ratio of the Unemployed and educated female labor force (% of population) of San Marino in 2005 to that in 2006?
Keep it short and to the point. 1.09. What is the ratio of the Unemployed and educated female labor force (% of population) in United States in 2005 to that in 2006?
Your answer should be compact. 1.11. What is the ratio of the Unemployed and educated female labor force (% of population) in Bulgaria in 2005 to that in 2007?
Your answer should be very brief. 0.86. What is the ratio of the Unemployed and educated female labor force (% of population) of Georgia in 2005 to that in 2007?
Keep it short and to the point. 0.58. What is the ratio of the Unemployed and educated female labor force (% of population) in San Marino in 2005 to that in 2007?
Provide a succinct answer. 1.17. What is the ratio of the Unemployed and educated female labor force (% of population) in United States in 2005 to that in 2007?
Provide a short and direct response. 1.12. What is the ratio of the Unemployed and educated female labor force (% of population) in San Marino in 2006 to that in 2007?
Your answer should be compact. 1.08. What is the difference between the highest and the second highest Unemployed and educated female labor force (% of population) in Bulgaria?
Ensure brevity in your answer.  0.4. What is the difference between the highest and the second highest Unemployed and educated female labor force (% of population) of Georgia?
Offer a very short reply. 0.6. What is the difference between the highest and the second highest Unemployed and educated female labor force (% of population) of San Marino?
Give a very brief answer. 2.7. What is the difference between the highest and the second highest Unemployed and educated female labor force (% of population) of United States?
Keep it short and to the point. 1.6. What is the difference between the highest and the lowest Unemployed and educated female labor force (% of population) in San Marino?
Your answer should be very brief. 25.7. What is the difference between the highest and the lowest Unemployed and educated female labor force (% of population) of United States?
Provide a short and direct response. 5.2. 